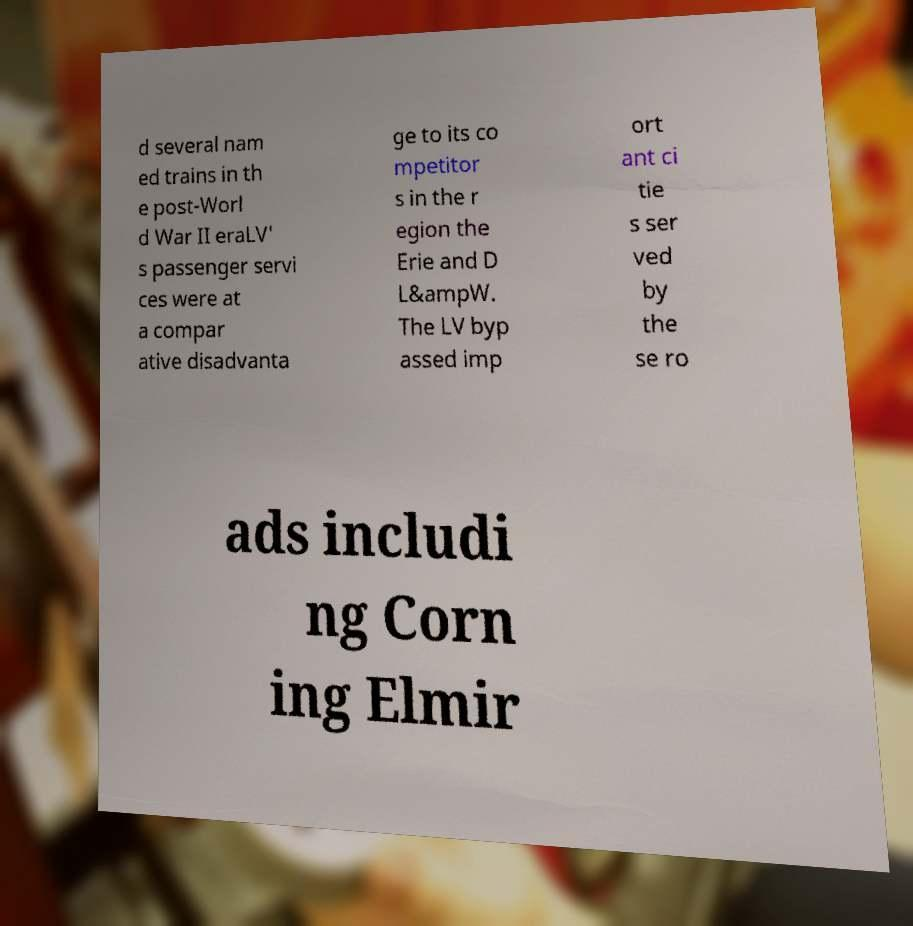Please read and relay the text visible in this image. What does it say? d several nam ed trains in th e post-Worl d War II eraLV' s passenger servi ces were at a compar ative disadvanta ge to its co mpetitor s in the r egion the Erie and D L&ampW. The LV byp assed imp ort ant ci tie s ser ved by the se ro ads includi ng Corn ing Elmir 